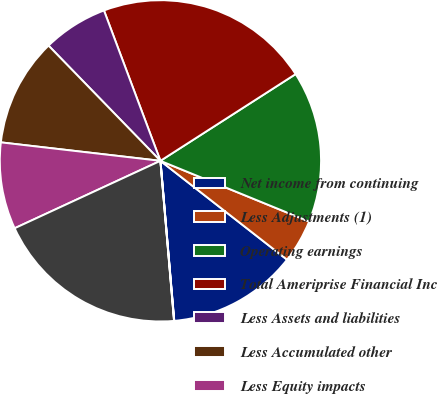Convert chart to OTSL. <chart><loc_0><loc_0><loc_500><loc_500><pie_chart><fcel>Net income from continuing<fcel>Less Adjustments (1)<fcel>Operating earnings<fcel>Total Ameriprise Financial Inc<fcel>Less Assets and liabilities<fcel>Less Accumulated other<fcel>Less Equity impacts<fcel>Operating equity<fcel>Return on equity from<nl><fcel>13.08%<fcel>4.38%<fcel>15.25%<fcel>21.64%<fcel>6.55%<fcel>10.9%<fcel>8.73%<fcel>19.46%<fcel>0.02%<nl></chart> 